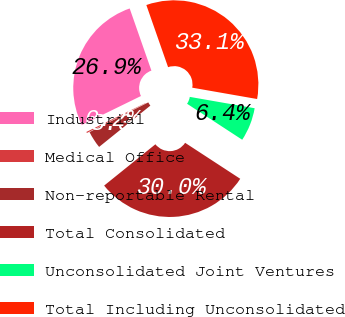Convert chart. <chart><loc_0><loc_0><loc_500><loc_500><pie_chart><fcel>Industrial<fcel>Medical Office<fcel>Non-reportable Rental<fcel>Total Consolidated<fcel>Unconsolidated Joint Ventures<fcel>Total Including Unconsolidated<nl><fcel>26.88%<fcel>0.22%<fcel>3.34%<fcel>30.0%<fcel>6.45%<fcel>33.11%<nl></chart> 